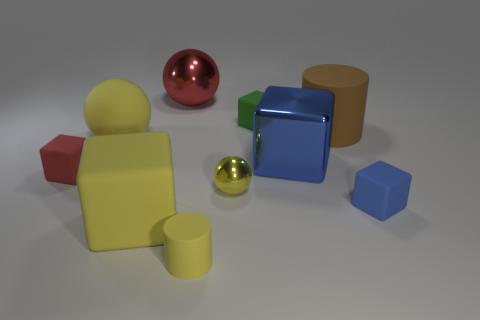Can you describe the arrangement of the objects in the image? Certainly! The image shows a collection of geometric shapes casually arranged on a flat surface. To the left, there's a reflective red sphere and behind it, a yellow cylinder. In the center, there's a prominent blue cube with a glossy finish, flanked by a golden sphere and a second cylinder in brown. Off to the right, there's a smaller blue cube, exhibiting a less reflective surface as compared to the central cube. 